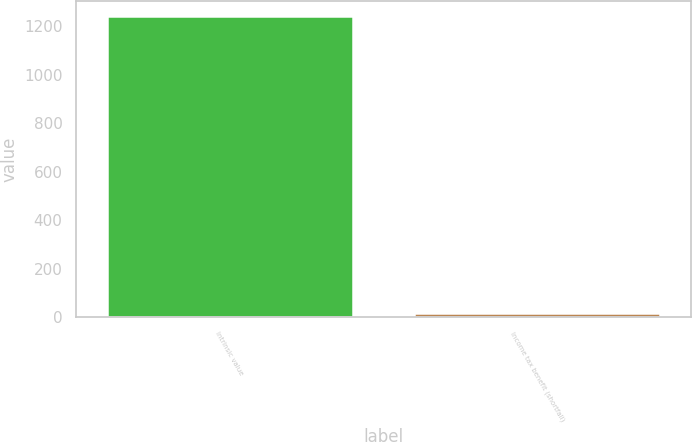Convert chart. <chart><loc_0><loc_0><loc_500><loc_500><bar_chart><fcel>Intrinsic value<fcel>Income tax benefit (shortfall)<nl><fcel>1241<fcel>15<nl></chart> 